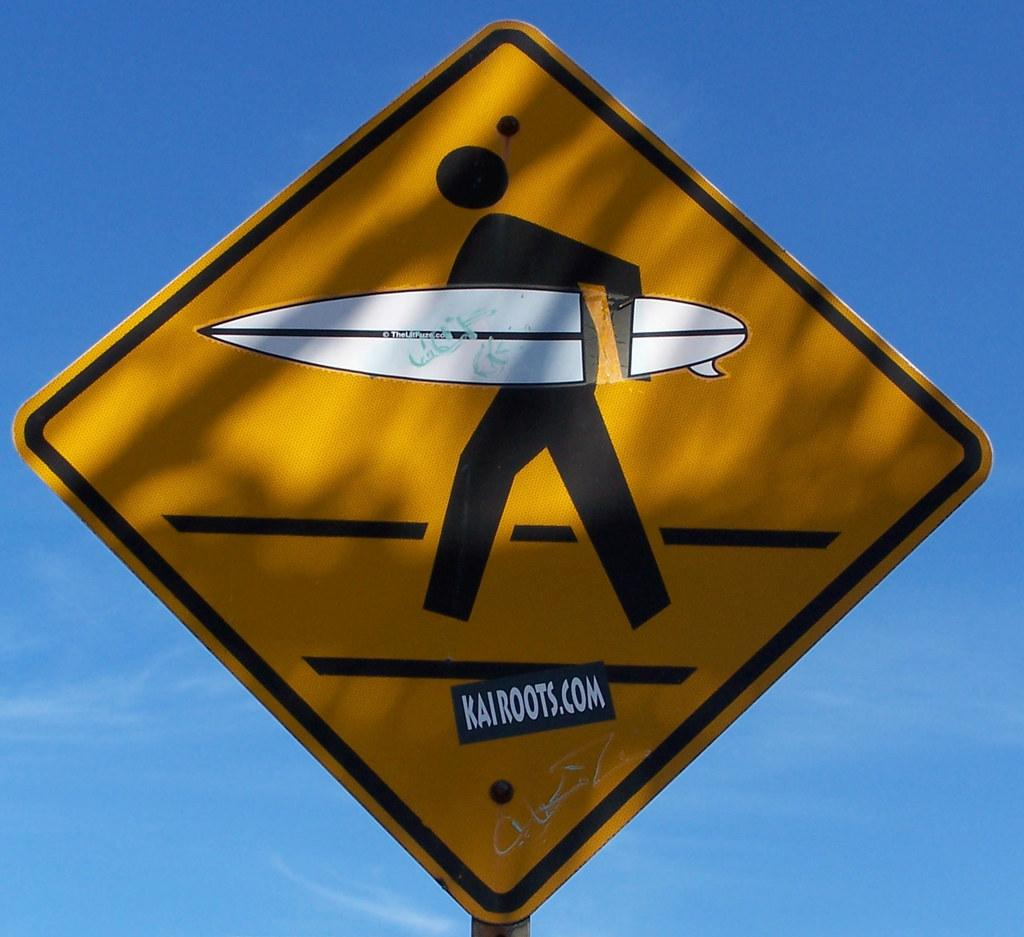What is the main object in the center of the image? There is a sign board in the center of the image. What can be found on the sign board? There is writing on the sign board. What can be seen in the background of the image? The sky is visible in the background of the image. What type of mask is being worn by the band in the image? There is no mask or band present in the image; it only features a sign board with writing and the sky in the background. 